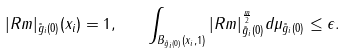<formula> <loc_0><loc_0><loc_500><loc_500>| R m | _ { \tilde { g } _ { i } ( 0 ) } ( x _ { i } ) = 1 , \quad \int _ { B _ { \tilde { g } _ { i } ( 0 ) } ( x _ { i } , 1 ) } | R m | _ { \tilde { g } _ { i } ( 0 ) } ^ { \frac { m } { 2 } } d \mu _ { \tilde { g } _ { i } ( 0 ) } \leq \epsilon .</formula> 